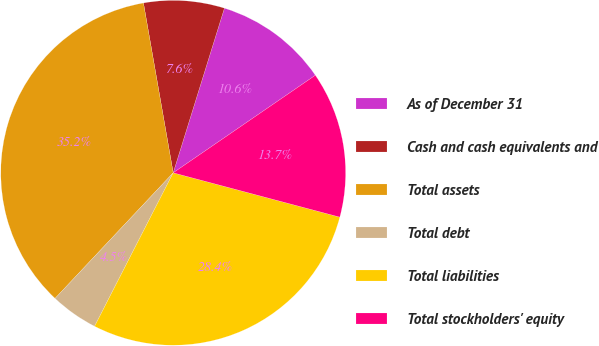Convert chart to OTSL. <chart><loc_0><loc_0><loc_500><loc_500><pie_chart><fcel>As of December 31<fcel>Cash and cash equivalents and<fcel>Total assets<fcel>Total debt<fcel>Total liabilities<fcel>Total stockholders' equity<nl><fcel>10.63%<fcel>7.56%<fcel>35.23%<fcel>4.48%<fcel>28.4%<fcel>13.71%<nl></chart> 